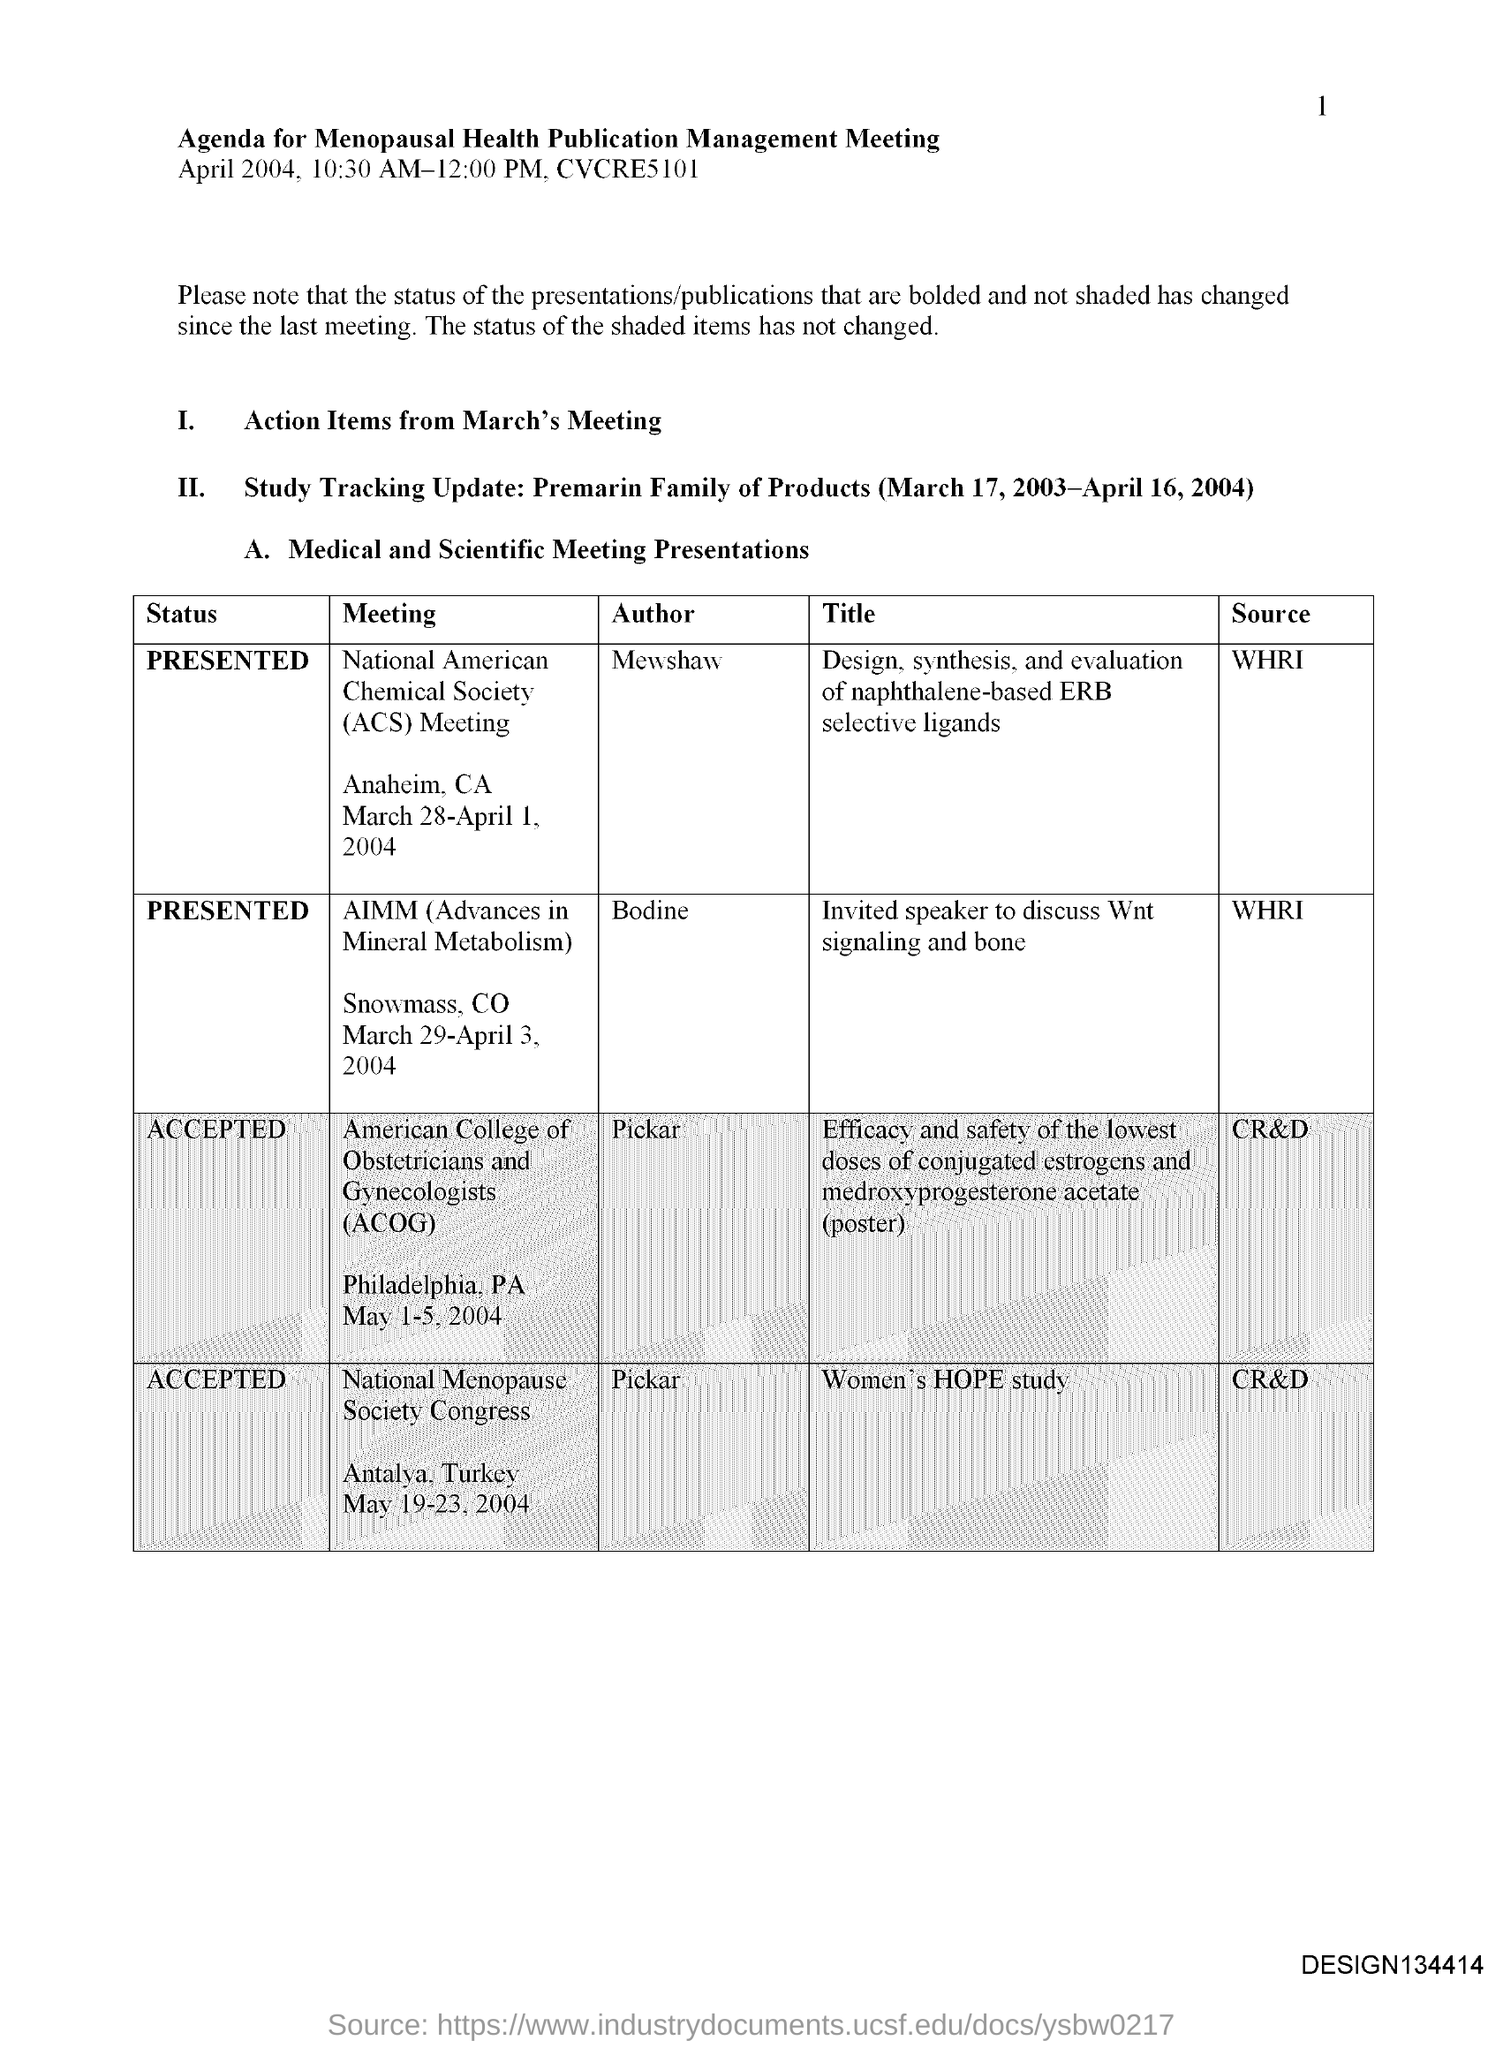List a handful of essential elements in this visual. AIMM stands for Advances in Mineral Metabolism, which refers to the latest research and developments in the field of studying the process by which living organisms obtain and use minerals. The title of the document is 'Agenda for Menopausal Health Publication Management Meeting.' The meeting known as the "National Menopause Society Congress" was authored by Pickar. The status of the meeting ACOG has been accepted. With each subsequent page, the reader is presented with a new number, ranging from 1 to the current page number. 